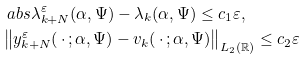Convert formula to latex. <formula><loc_0><loc_0><loc_500><loc_500>& \ a b s { \lambda _ { k + N } ^ { \varepsilon } ( \alpha , \Psi ) - \lambda _ { k } ( \alpha , \Psi ) } \leq c _ { 1 } \varepsilon , \\ & \left \| y _ { k + N } ^ { \varepsilon } ( \, \cdot \, ; \alpha , \Psi ) - v _ { k } ( \, \cdot \, ; \alpha , \Psi ) \right \| _ { L _ { 2 } ( \mathbb { R } ) } \leq c _ { 2 } \varepsilon</formula> 